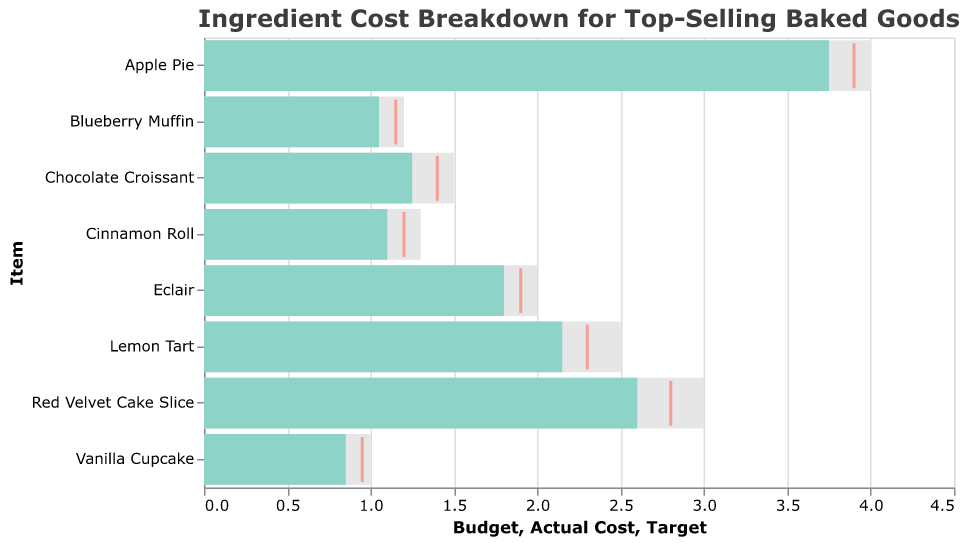Which item has the highest actual cost? By examining the length of the bars representing actual costs, we see that the Apple Pie bar is the longest, indicating it has the highest actual cost.
Answer: Apple Pie What is the title of the chart? The title of the chart is displayed prominently at the top of the figure.
Answer: Ingredient Cost Breakdown for Top-Selling Baked Goods How many items have an actual cost lower than the target cost? Compare the length of the Actual Cost bars (blue) with the position of the Target ticks (red). Count the items where the Actual Cost bar is shorter than the Target tick.
Answer: 3 Which item is closest to its target cost? Find the item where the position of the Target tick (red) closely aligns with the length of the Actual Cost bar (blue).
Answer: Blueberry Muffin What is the difference between the budget and actual cost of the Lemon Tart? Subtract the actual cost of the Lemon Tart from its budget: 2.50 - 2.15 = 0.35.
Answer: 0.35 Is the actual cost of the Red Velvet Cake Slice below, on, or above the budget? Compare the length of the Actual Cost bar (blue) with the length of the Budget bar (gray) for the Red Velvet Cake Slice. The Actual Cost bar is shorter than the Budget bar.
Answer: Below Which item has the smallest difference between the actual cost and the budget? Calculate the difference between the Budget and Actual Cost for each item and find the smallest value. The smallest difference is for the Blueberry Muffin.
Answer: Blueberry Muffin 